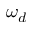Convert formula to latex. <formula><loc_0><loc_0><loc_500><loc_500>\omega _ { d }</formula> 